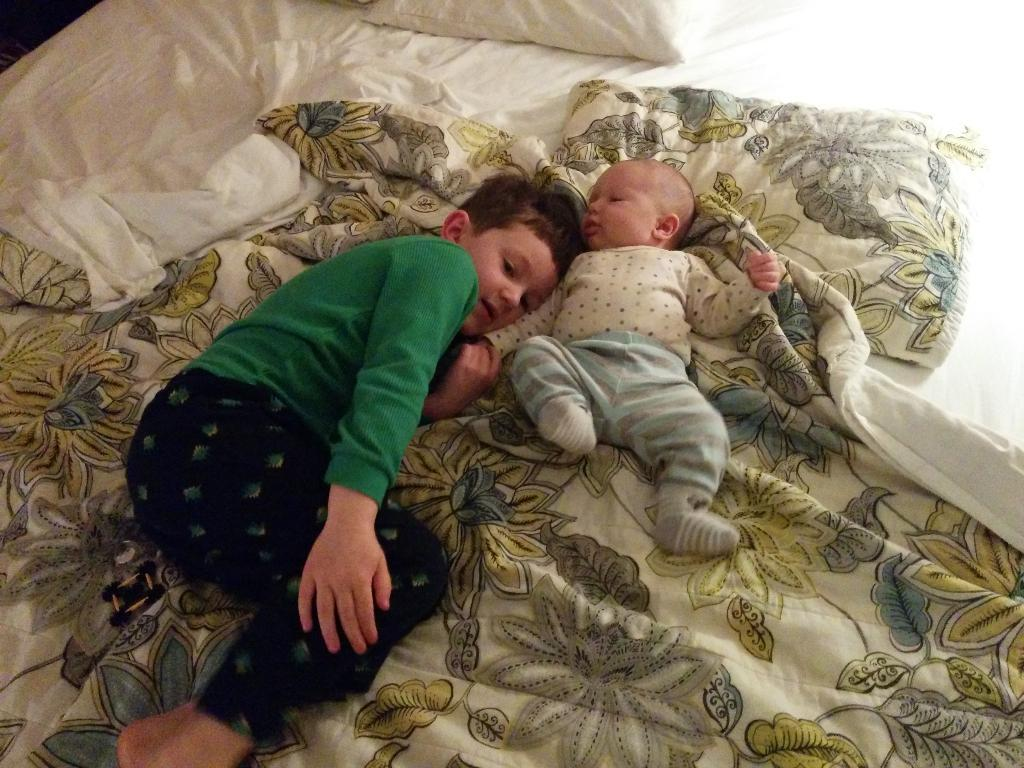What is the main subject of the image? The main subjects of the image are a child and a baby. What are the child and baby doing in the image? Both the child and baby are sleeping in the image. Where are the child and baby located in the image? The child and baby are on a bed in the image. What else can be seen on the bed? There are pillows on the bed. What type of insurance policy is the child holding in the image? There is no insurance policy present in the image; the child and baby are both sleeping on a bed. 